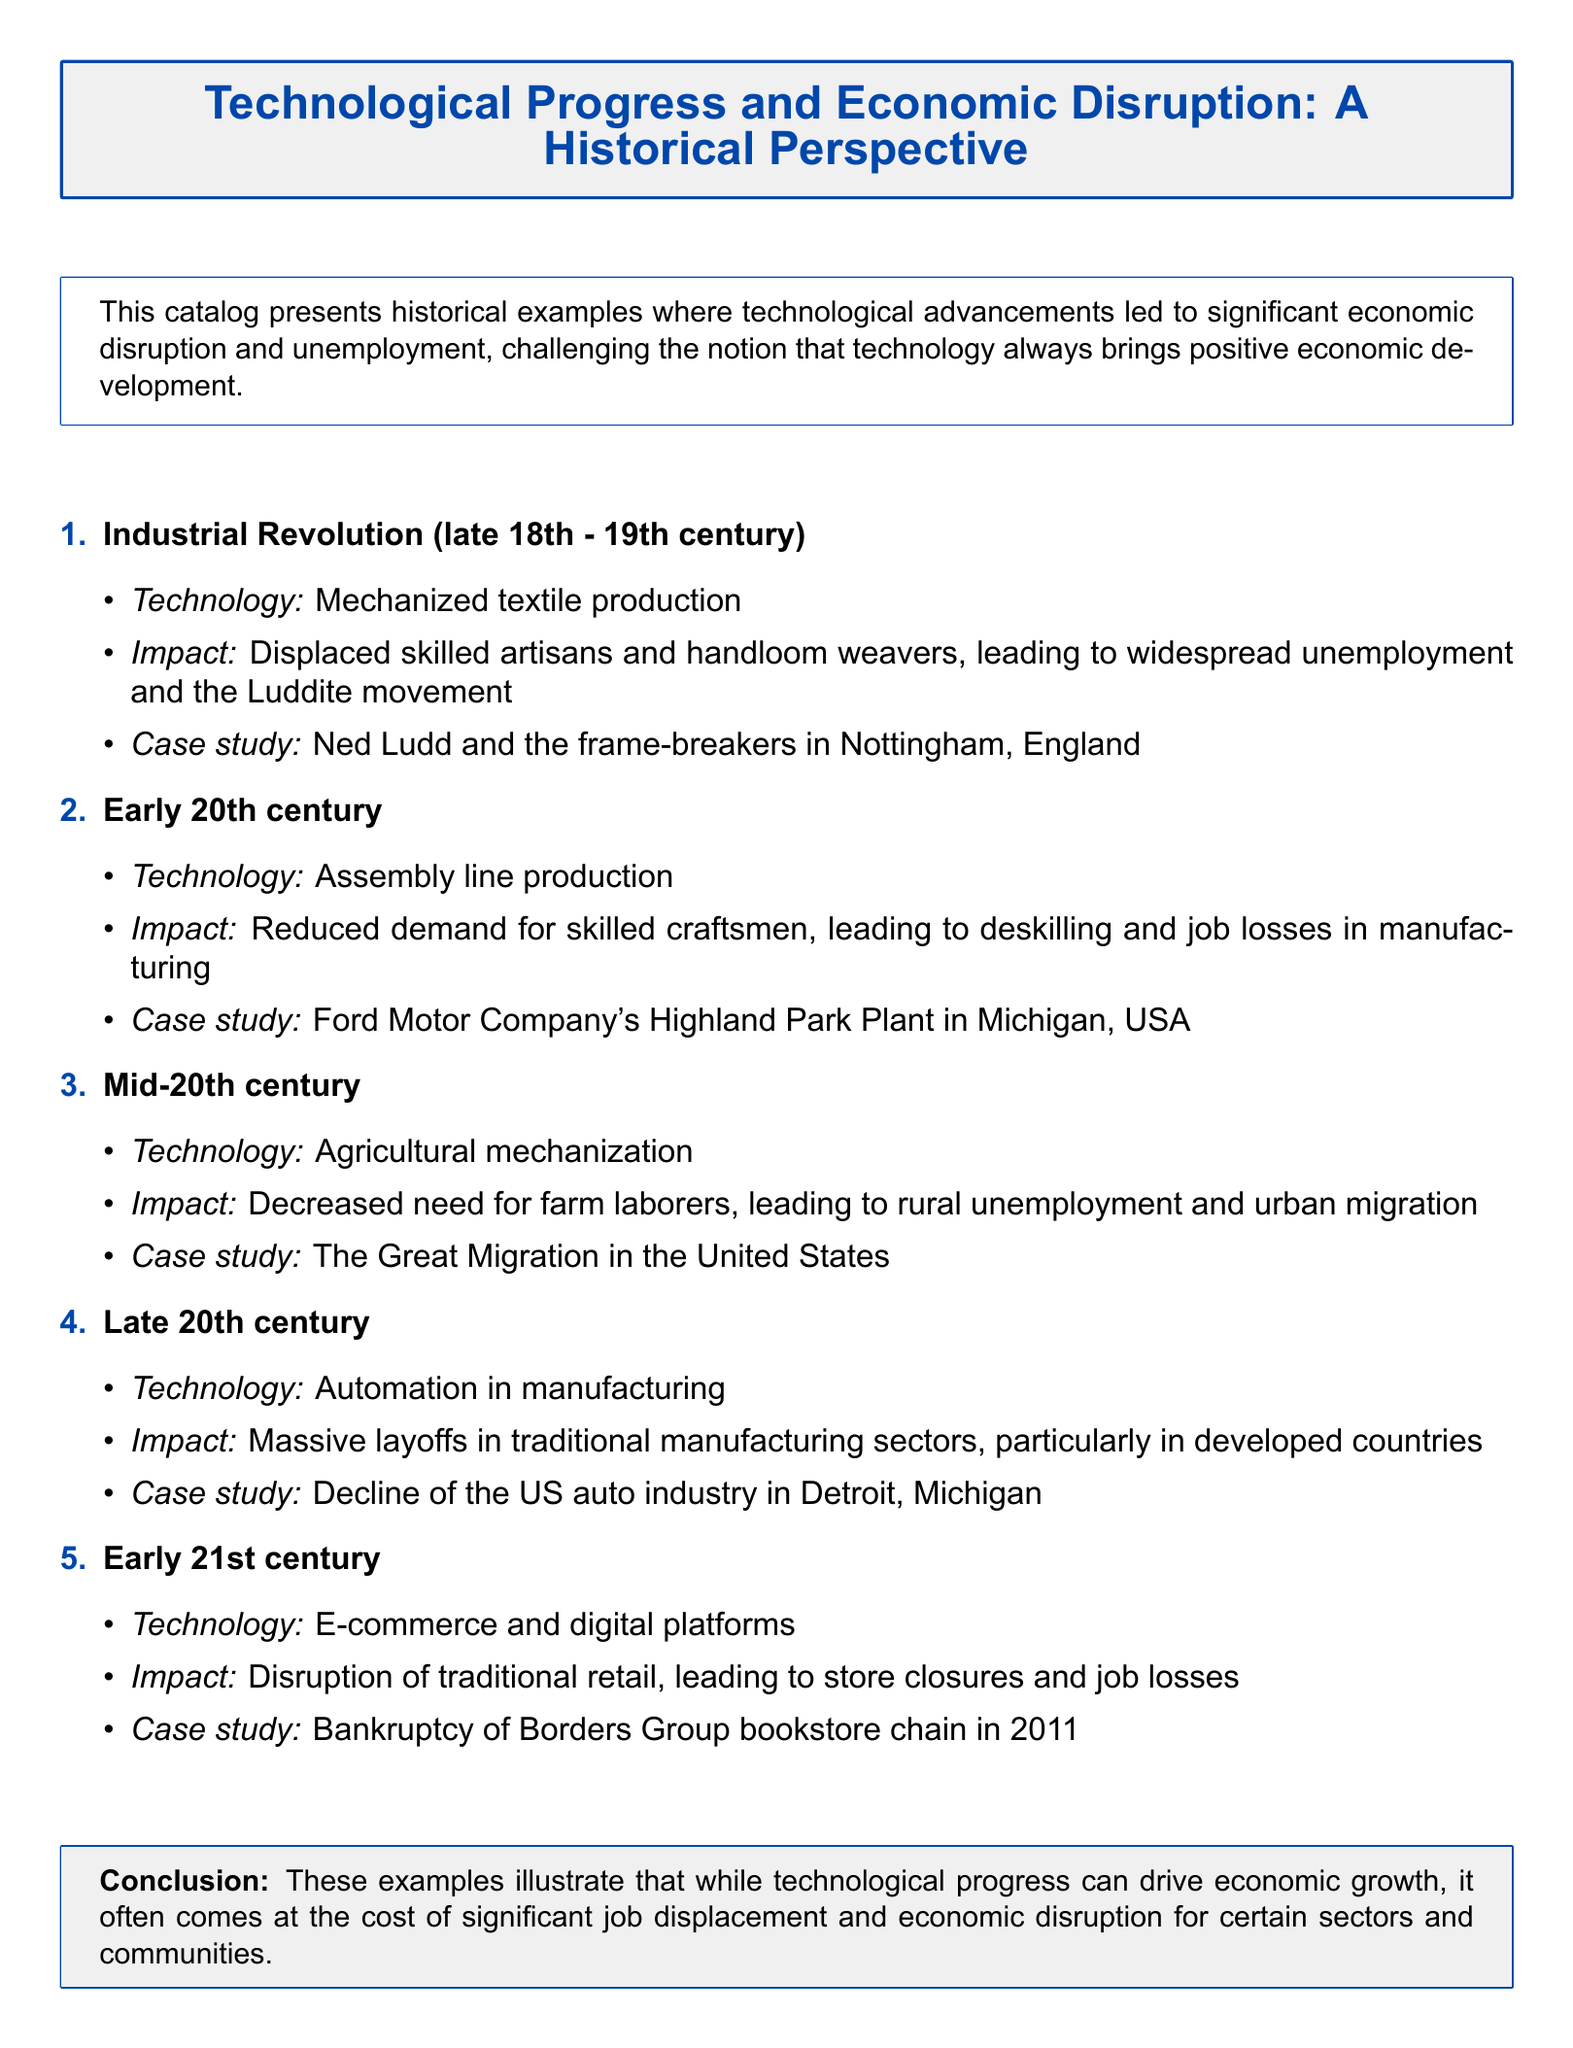What was the technology used during the Industrial Revolution? The technology mentioned is mechanized textile production, which caused economic disruption.
Answer: Mechanized textile production What movement was associated with the unemployment caused by the Industrial Revolution? The document mentions the Luddite movement as a response to job losses during this period.
Answer: Luddite movement What year was Borders Group bookstore chain's bankruptcy? The document states that Borders Group filed for bankruptcy in 2011, highlighting the impact of e-commerce on traditional retail.
Answer: 2011 What impact did assembly line production have in the early 20th century? It reduced demand for skilled craftsmen, leading to deskilling and job losses in manufacturing.
Answer: Deskilling and job losses Which city experienced a decline in the auto industry due to automation? The document provides Detroit, Michigan as the case study for massive layoffs in traditional manufacturing sectors.
Answer: Detroit, Michigan What was a consequence of agricultural mechanization in the mid-20th century? Decreased need for farm laborers led to rural unemployment and migration to urban areas.
Answer: Rural unemployment and urban migration Which case study is associated with the Great Migration? The document indicates that the Great Migration in the United States is a consequence of agricultural mechanization.
Answer: The Great Migration What is the conclusion of the catalog regarding technological progress? The document concludes that technological progress can drive economic growth but often leads to job displacement.
Answer: Job displacement 